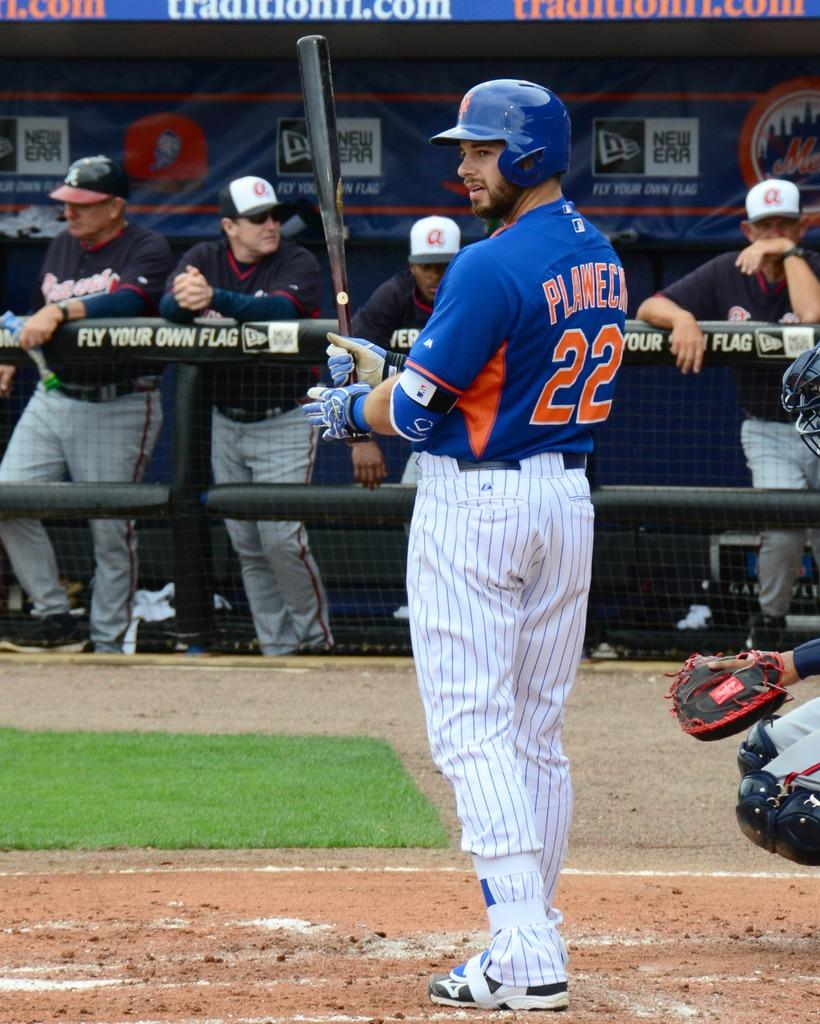What is the primary setting of the image? There is a ground in the image. What is the person holding in the image? The person is holding a bat. Who else is present in the image besides the person with the bat? There are people in the image who appear to be an audience. What is the purpose of the fence or fencing in the image? The fence or fencing in the image may serve as a boundary or barrier. What type of rat can be seen in the image? There is no rat present in the image. What are the people in the audience watching in the image? The image does not provide any information about what the audience is watching. 